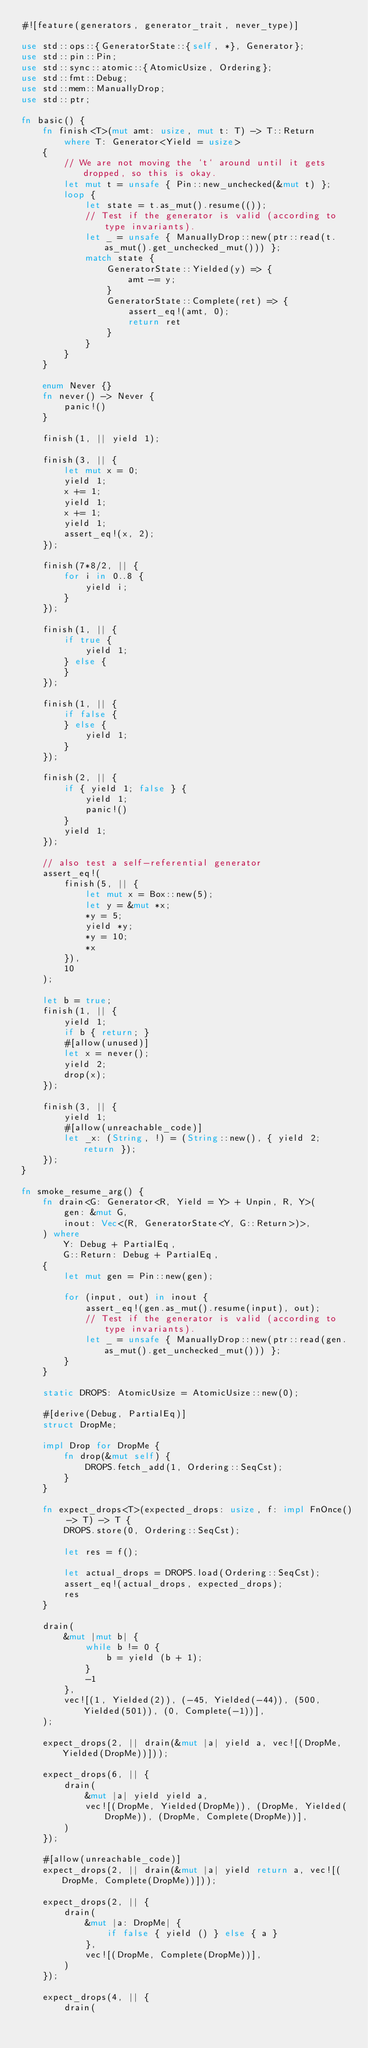Convert code to text. <code><loc_0><loc_0><loc_500><loc_500><_Rust_>#![feature(generators, generator_trait, never_type)]

use std::ops::{GeneratorState::{self, *}, Generator};
use std::pin::Pin;
use std::sync::atomic::{AtomicUsize, Ordering};
use std::fmt::Debug;
use std::mem::ManuallyDrop;
use std::ptr;

fn basic() {
    fn finish<T>(mut amt: usize, mut t: T) -> T::Return
        where T: Generator<Yield = usize>
    {
        // We are not moving the `t` around until it gets dropped, so this is okay.
        let mut t = unsafe { Pin::new_unchecked(&mut t) };
        loop {
            let state = t.as_mut().resume(());
            // Test if the generator is valid (according to type invariants).
            let _ = unsafe { ManuallyDrop::new(ptr::read(t.as_mut().get_unchecked_mut())) };
            match state {
                GeneratorState::Yielded(y) => {
                    amt -= y;
                }
                GeneratorState::Complete(ret) => {
                    assert_eq!(amt, 0);
                    return ret
                }
            }
        }
    }

    enum Never {}
    fn never() -> Never {
        panic!()
    }

    finish(1, || yield 1);

    finish(3, || {
        let mut x = 0;
        yield 1;
        x += 1;
        yield 1;
        x += 1;
        yield 1;
        assert_eq!(x, 2);
    });

    finish(7*8/2, || {
        for i in 0..8 {
            yield i;
        }
    });

    finish(1, || {
        if true {
            yield 1;
        } else {
        }
    });

    finish(1, || {
        if false {
        } else {
            yield 1;
        }
    });

    finish(2, || {
        if { yield 1; false } {
            yield 1;
            panic!()
        }
        yield 1;
    });

    // also test a self-referential generator
    assert_eq!(
        finish(5, || {
            let mut x = Box::new(5);
            let y = &mut *x;
            *y = 5;
            yield *y;
            *y = 10;
            *x
        }),
        10
    );

    let b = true;
    finish(1, || {
        yield 1;
        if b { return; }
        #[allow(unused)]
        let x = never();
        yield 2;
        drop(x);
    });

    finish(3, || {
        yield 1;
        #[allow(unreachable_code)]
        let _x: (String, !) = (String::new(), { yield 2; return });
    });
}

fn smoke_resume_arg() {
    fn drain<G: Generator<R, Yield = Y> + Unpin, R, Y>(
        gen: &mut G,
        inout: Vec<(R, GeneratorState<Y, G::Return>)>,
    ) where
        Y: Debug + PartialEq,
        G::Return: Debug + PartialEq,
    {
        let mut gen = Pin::new(gen);

        for (input, out) in inout {
            assert_eq!(gen.as_mut().resume(input), out);
            // Test if the generator is valid (according to type invariants).
            let _ = unsafe { ManuallyDrop::new(ptr::read(gen.as_mut().get_unchecked_mut())) };
        }
    }

    static DROPS: AtomicUsize = AtomicUsize::new(0);

    #[derive(Debug, PartialEq)]
    struct DropMe;

    impl Drop for DropMe {
        fn drop(&mut self) {
            DROPS.fetch_add(1, Ordering::SeqCst);
        }
    }

    fn expect_drops<T>(expected_drops: usize, f: impl FnOnce() -> T) -> T {
        DROPS.store(0, Ordering::SeqCst);

        let res = f();

        let actual_drops = DROPS.load(Ordering::SeqCst);
        assert_eq!(actual_drops, expected_drops);
        res
    }

    drain(
        &mut |mut b| {
            while b != 0 {
                b = yield (b + 1);
            }
            -1
        },
        vec![(1, Yielded(2)), (-45, Yielded(-44)), (500, Yielded(501)), (0, Complete(-1))],
    );

    expect_drops(2, || drain(&mut |a| yield a, vec![(DropMe, Yielded(DropMe))]));

    expect_drops(6, || {
        drain(
            &mut |a| yield yield a,
            vec![(DropMe, Yielded(DropMe)), (DropMe, Yielded(DropMe)), (DropMe, Complete(DropMe))],
        )
    });

    #[allow(unreachable_code)]
    expect_drops(2, || drain(&mut |a| yield return a, vec![(DropMe, Complete(DropMe))]));

    expect_drops(2, || {
        drain(
            &mut |a: DropMe| {
                if false { yield () } else { a }
            },
            vec![(DropMe, Complete(DropMe))],
        )
    });

    expect_drops(4, || {
        drain(</code> 